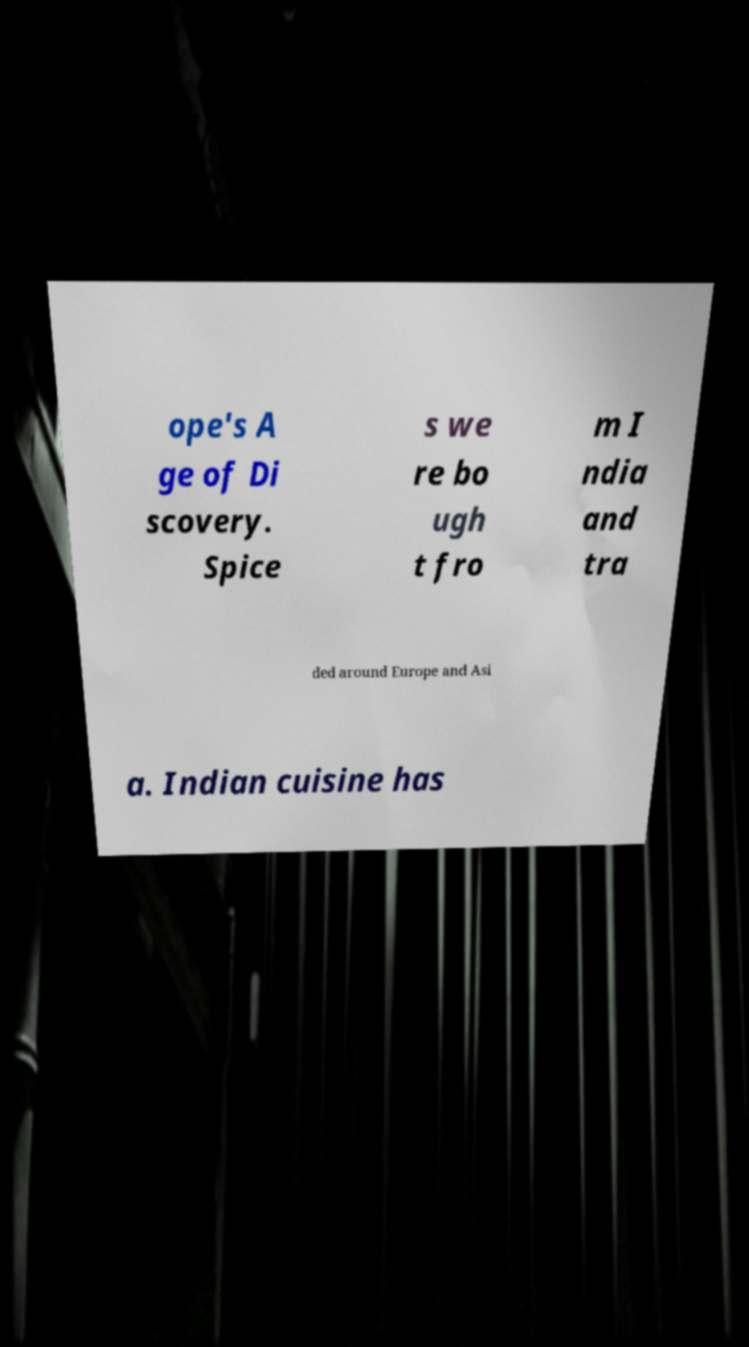Can you read and provide the text displayed in the image?This photo seems to have some interesting text. Can you extract and type it out for me? ope's A ge of Di scovery. Spice s we re bo ugh t fro m I ndia and tra ded around Europe and Asi a. Indian cuisine has 